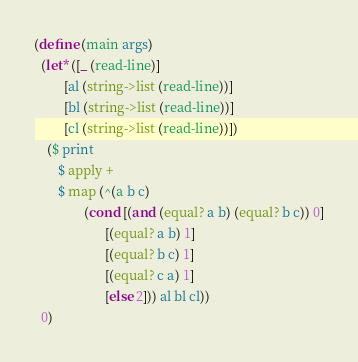<code> <loc_0><loc_0><loc_500><loc_500><_Scheme_>(define (main args)
  (let* ([_ (read-line)]
         [al (string->list (read-line))]
         [bl (string->list (read-line))]
         [cl (string->list (read-line))])
    ($ print
       $ apply +
       $ map (^(a b c)
               (cond [(and (equal? a b) (equal? b c)) 0]
                     [(equal? a b) 1]
                     [(equal? b c) 1]
                     [(equal? c a) 1]
                     [else 2])) al bl cl))
  0)
</code> 